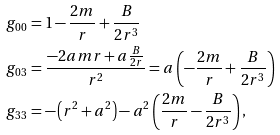<formula> <loc_0><loc_0><loc_500><loc_500>g _ { 0 0 } & = 1 - \frac { 2 m } { r } + \frac { B } { 2 r ^ { 3 } } \\ g _ { 0 3 } & = \frac { - 2 a m r + a \frac { B } { 2 r } } { r ^ { 2 } } = a \left ( - \frac { 2 m } { r } + \frac { B } { 2 r ^ { 3 } } \right ) \\ g _ { 3 3 } & = - \left ( r ^ { 2 } + a ^ { 2 } \right ) - a ^ { 2 } \left ( \frac { 2 m } { r } - \frac { B } { 2 r ^ { 3 } } \right ) ,</formula> 